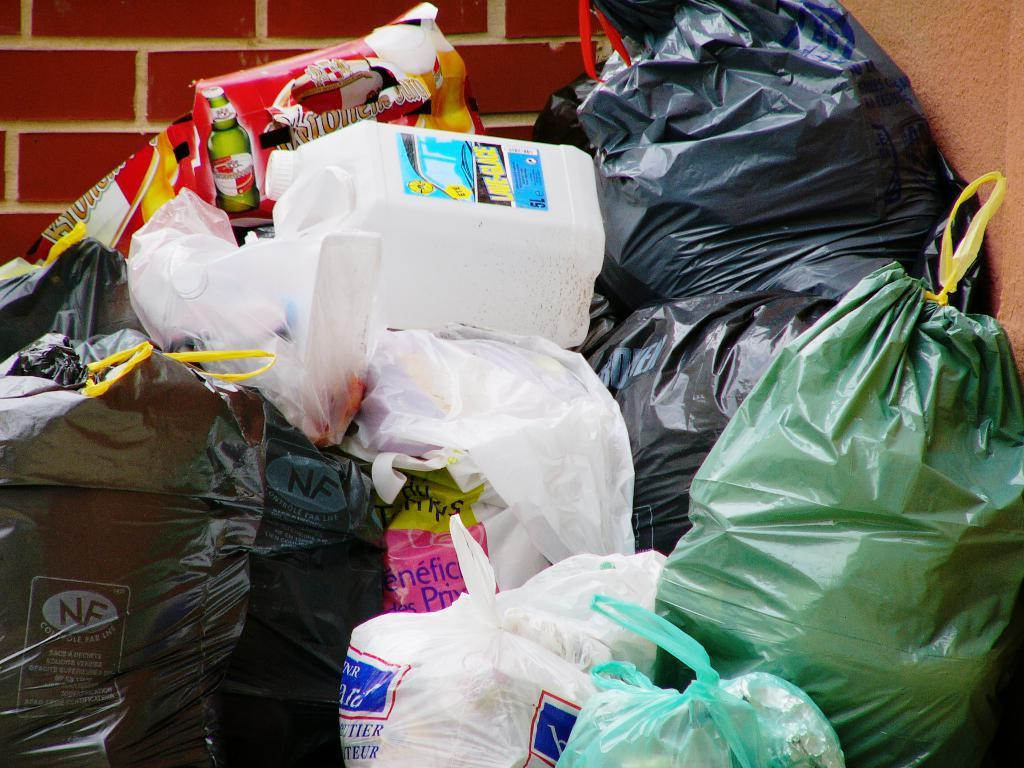What type of objects are present in the image? There are plastic bags and a white-colored can in the image. What can be seen in the background of the image? There is a wall in the image. How many dinosaurs are visible in the image? There are no dinosaurs present in the image. 